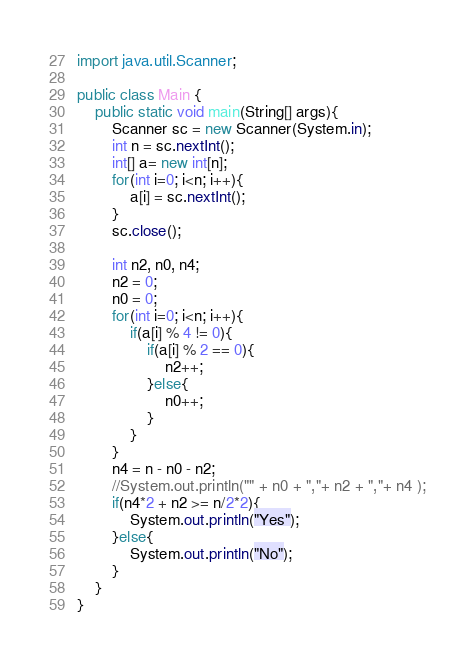<code> <loc_0><loc_0><loc_500><loc_500><_Java_>import java.util.Scanner;

public class Main {
	public static void main(String[] args){
		Scanner sc = new Scanner(System.in);
		int n = sc.nextInt();
		int[] a= new int[n];
		for(int i=0; i<n; i++){
			a[i] = sc.nextInt();
		}
		sc.close();
		
		int n2, n0, n4;
		n2 = 0;
		n0 = 0;
		for(int i=0; i<n; i++){
			if(a[i] % 4 != 0){
				if(a[i] % 2 == 0){
					n2++;
				}else{
					n0++;
				}
			}
		}
		n4 = n - n0 - n2;
		//System.out.println("" + n0 + ","+ n2 + ","+ n4 );
		if(n4*2 + n2 >= n/2*2){
			System.out.println("Yes");
		}else{
			System.out.println("No");
		}
	}
}</code> 